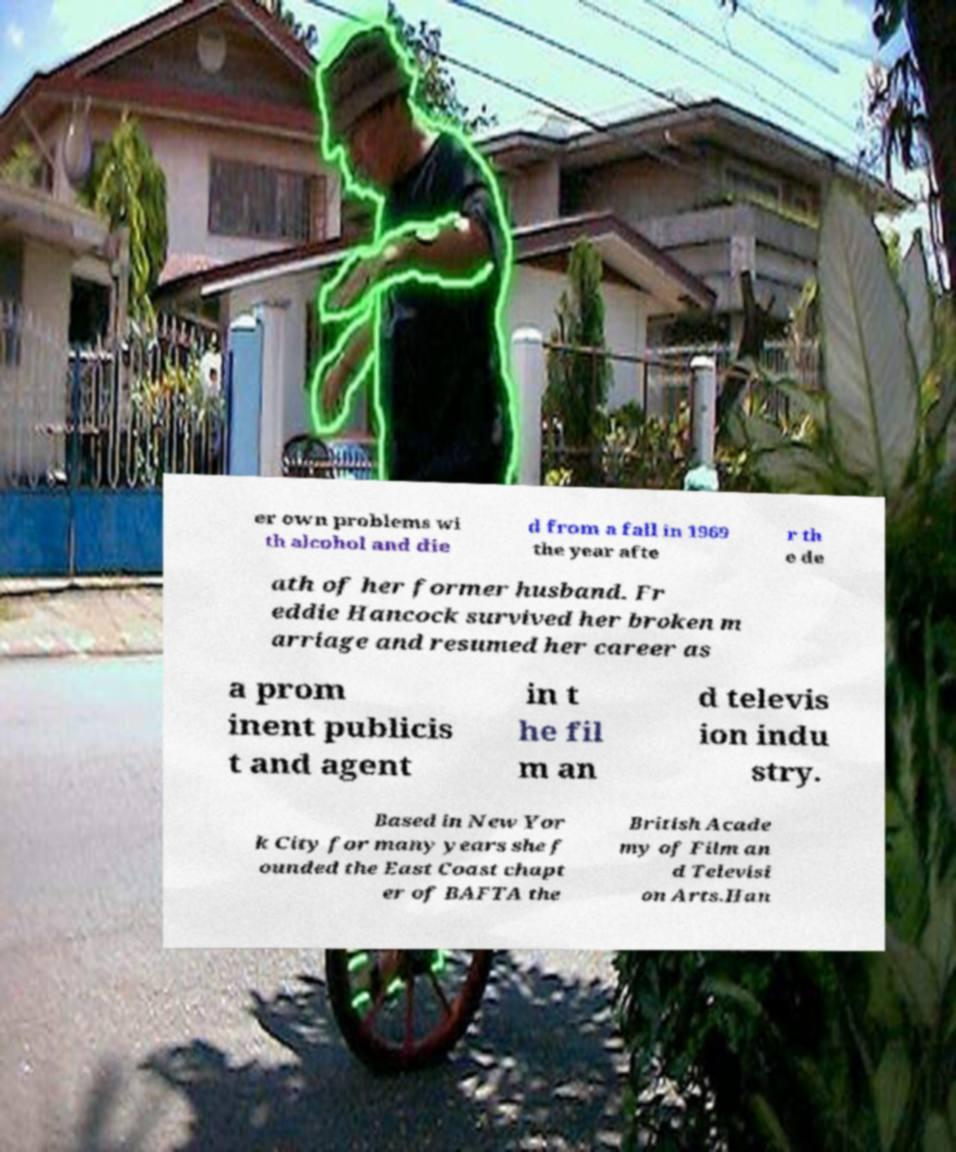Please identify and transcribe the text found in this image. er own problems wi th alcohol and die d from a fall in 1969 the year afte r th e de ath of her former husband. Fr eddie Hancock survived her broken m arriage and resumed her career as a prom inent publicis t and agent in t he fil m an d televis ion indu stry. Based in New Yor k City for many years she f ounded the East Coast chapt er of BAFTA the British Acade my of Film an d Televisi on Arts.Han 